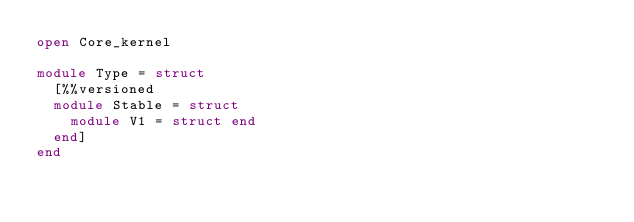<code> <loc_0><loc_0><loc_500><loc_500><_OCaml_>open Core_kernel

module Type = struct
  [%%versioned
  module Stable = struct
    module V1 = struct end
  end]
end
</code> 